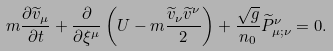<formula> <loc_0><loc_0><loc_500><loc_500>m \frac { \partial \widetilde { v } _ { \mu } } { \partial t } + \frac { \partial } { \partial \xi ^ { \mu } } \left ( U - m \frac { \widetilde { v } _ { \nu } \widetilde { v } ^ { \nu } } { 2 } \right ) + \frac { \sqrt { g } } { n _ { 0 } } \widetilde { P } ^ { \nu } _ { \mu ; \nu } = 0 .</formula> 